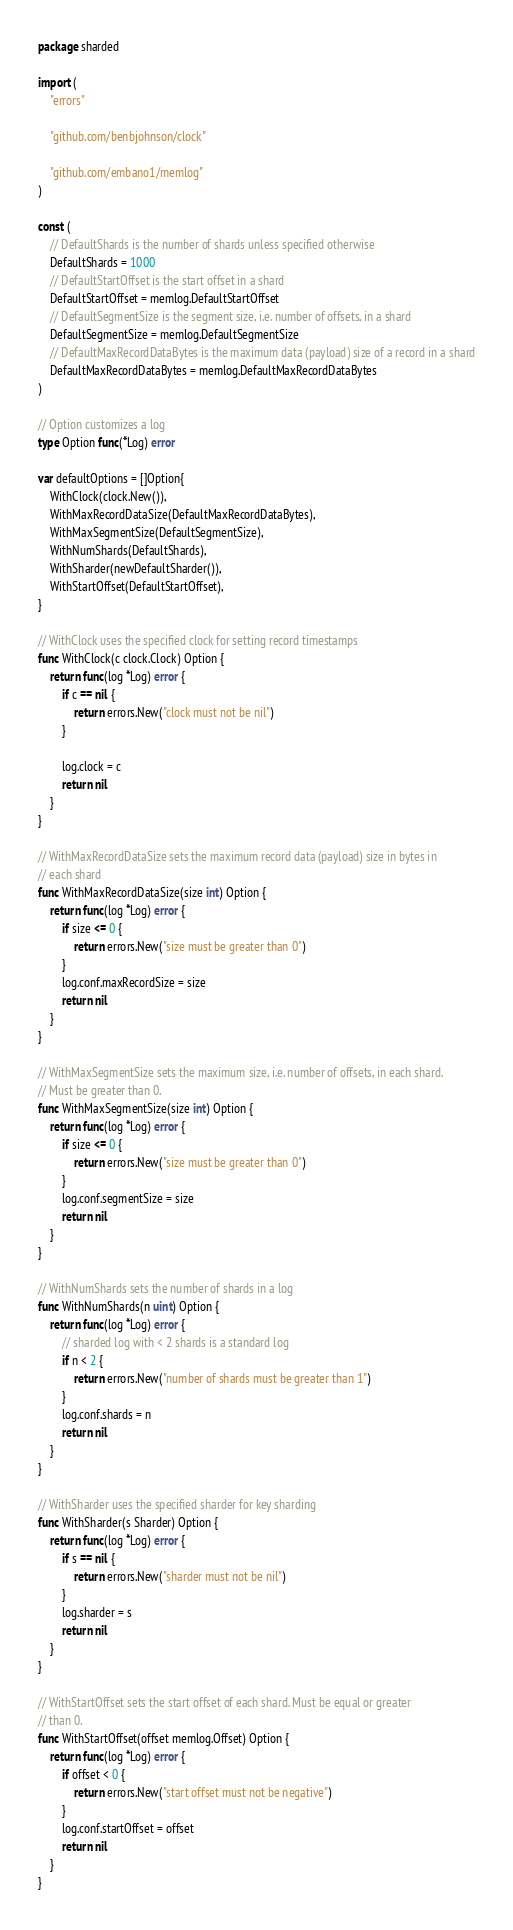Convert code to text. <code><loc_0><loc_0><loc_500><loc_500><_Go_>package sharded

import (
	"errors"

	"github.com/benbjohnson/clock"

	"github.com/embano1/memlog"
)

const (
	// DefaultShards is the number of shards unless specified otherwise
	DefaultShards = 1000
	// DefaultStartOffset is the start offset in a shard
	DefaultStartOffset = memlog.DefaultStartOffset
	// DefaultSegmentSize is the segment size, i.e. number of offsets, in a shard
	DefaultSegmentSize = memlog.DefaultSegmentSize
	// DefaultMaxRecordDataBytes is the maximum data (payload) size of a record in a shard
	DefaultMaxRecordDataBytes = memlog.DefaultMaxRecordDataBytes
)

// Option customizes a log
type Option func(*Log) error

var defaultOptions = []Option{
	WithClock(clock.New()),
	WithMaxRecordDataSize(DefaultMaxRecordDataBytes),
	WithMaxSegmentSize(DefaultSegmentSize),
	WithNumShards(DefaultShards),
	WithSharder(newDefaultSharder()),
	WithStartOffset(DefaultStartOffset),
}

// WithClock uses the specified clock for setting record timestamps
func WithClock(c clock.Clock) Option {
	return func(log *Log) error {
		if c == nil {
			return errors.New("clock must not be nil")
		}

		log.clock = c
		return nil
	}
}

// WithMaxRecordDataSize sets the maximum record data (payload) size in bytes in
// each shard
func WithMaxRecordDataSize(size int) Option {
	return func(log *Log) error {
		if size <= 0 {
			return errors.New("size must be greater than 0")
		}
		log.conf.maxRecordSize = size
		return nil
	}
}

// WithMaxSegmentSize sets the maximum size, i.e. number of offsets, in each shard.
// Must be greater than 0.
func WithMaxSegmentSize(size int) Option {
	return func(log *Log) error {
		if size <= 0 {
			return errors.New("size must be greater than 0")
		}
		log.conf.segmentSize = size
		return nil
	}
}

// WithNumShards sets the number of shards in a log
func WithNumShards(n uint) Option {
	return func(log *Log) error {
		// sharded log with < 2 shards is a standard log
		if n < 2 {
			return errors.New("number of shards must be greater than 1")
		}
		log.conf.shards = n
		return nil
	}
}

// WithSharder uses the specified sharder for key sharding
func WithSharder(s Sharder) Option {
	return func(log *Log) error {
		if s == nil {
			return errors.New("sharder must not be nil")
		}
		log.sharder = s
		return nil
	}
}

// WithStartOffset sets the start offset of each shard. Must be equal or greater
// than 0.
func WithStartOffset(offset memlog.Offset) Option {
	return func(log *Log) error {
		if offset < 0 {
			return errors.New("start offset must not be negative")
		}
		log.conf.startOffset = offset
		return nil
	}
}
</code> 